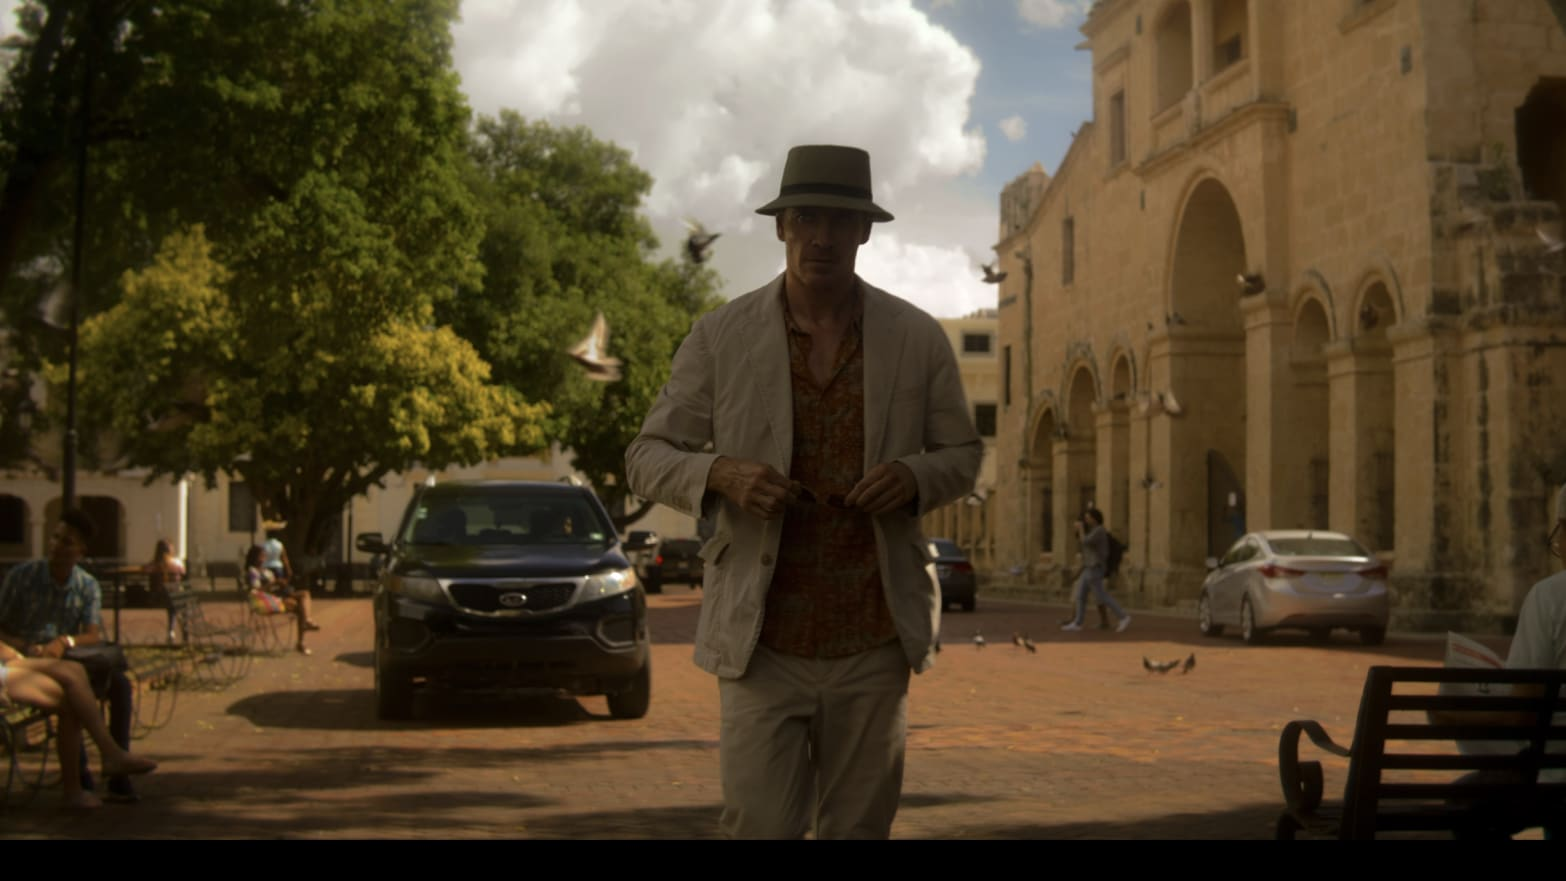What insights can you provide about his clothing style? The man's outfit is stylish yet suitable for warm weather, comprising a white fedora, a light beige jacket, and a loose-fitting shirt. His attire reflects a blend of comfort and elegance, appropriate for walking through a sunny, bustling area. Does his style indicate anything about his possible activities or status? His fashion choices suggest a sense of leisure mixed with a smart casual look, potentially indicating he is either a local enjoying a relaxed day or a tourist engaged in sightseeing, given the lively and culturally vivid setting. 